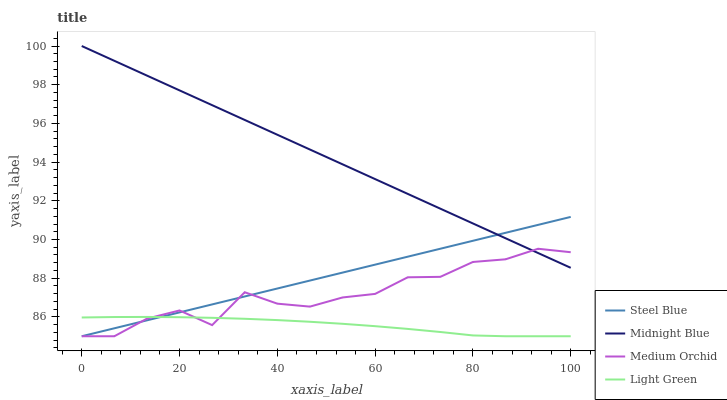Does Light Green have the minimum area under the curve?
Answer yes or no. Yes. Does Midnight Blue have the maximum area under the curve?
Answer yes or no. Yes. Does Steel Blue have the minimum area under the curve?
Answer yes or no. No. Does Steel Blue have the maximum area under the curve?
Answer yes or no. No. Is Steel Blue the smoothest?
Answer yes or no. Yes. Is Medium Orchid the roughest?
Answer yes or no. Yes. Is Light Green the smoothest?
Answer yes or no. No. Is Light Green the roughest?
Answer yes or no. No. Does Medium Orchid have the lowest value?
Answer yes or no. Yes. Does Midnight Blue have the lowest value?
Answer yes or no. No. Does Midnight Blue have the highest value?
Answer yes or no. Yes. Does Steel Blue have the highest value?
Answer yes or no. No. Is Light Green less than Midnight Blue?
Answer yes or no. Yes. Is Midnight Blue greater than Light Green?
Answer yes or no. Yes. Does Midnight Blue intersect Steel Blue?
Answer yes or no. Yes. Is Midnight Blue less than Steel Blue?
Answer yes or no. No. Is Midnight Blue greater than Steel Blue?
Answer yes or no. No. Does Light Green intersect Midnight Blue?
Answer yes or no. No. 